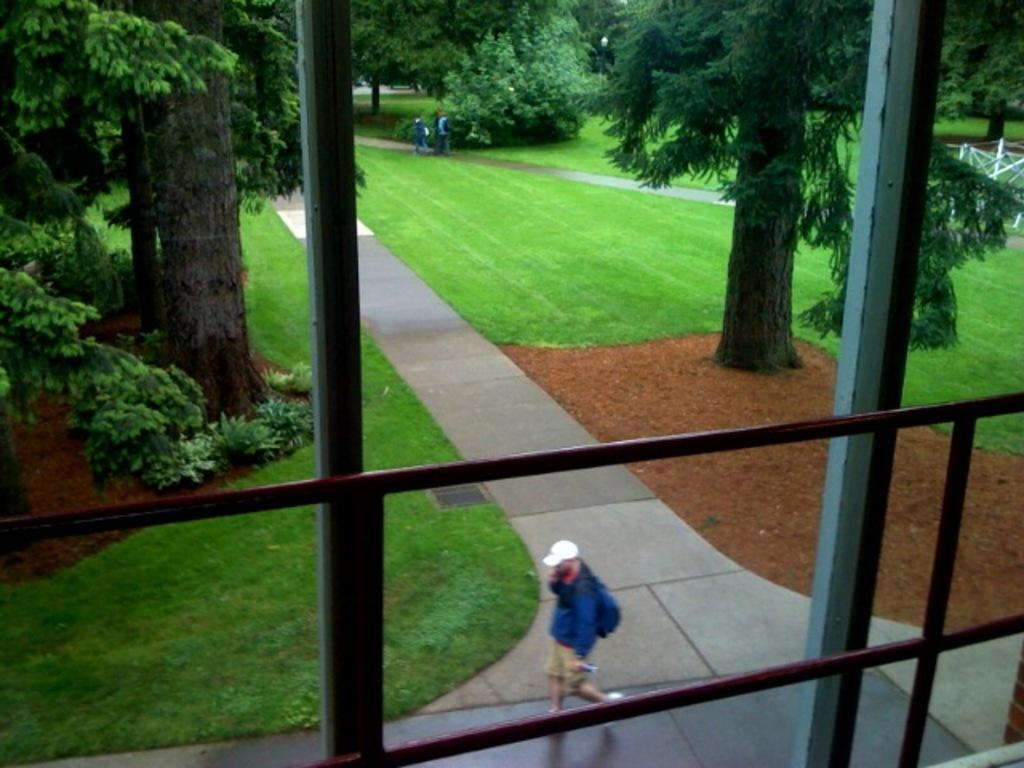What are the people in the image doing? The people in the image are walking. What type of vegetation is present in the image? There are trees in the image. What type of ground surface is visible in the image? There is grass and pavement in the image. What type of material is present in the image? There are metal rods in the image. What is the square's role in the image? There is no square present in the image. How does the expansion affect the people walking in the image? There is no expansion mentioned in the image, and the people walking are not affected by any expansion. 